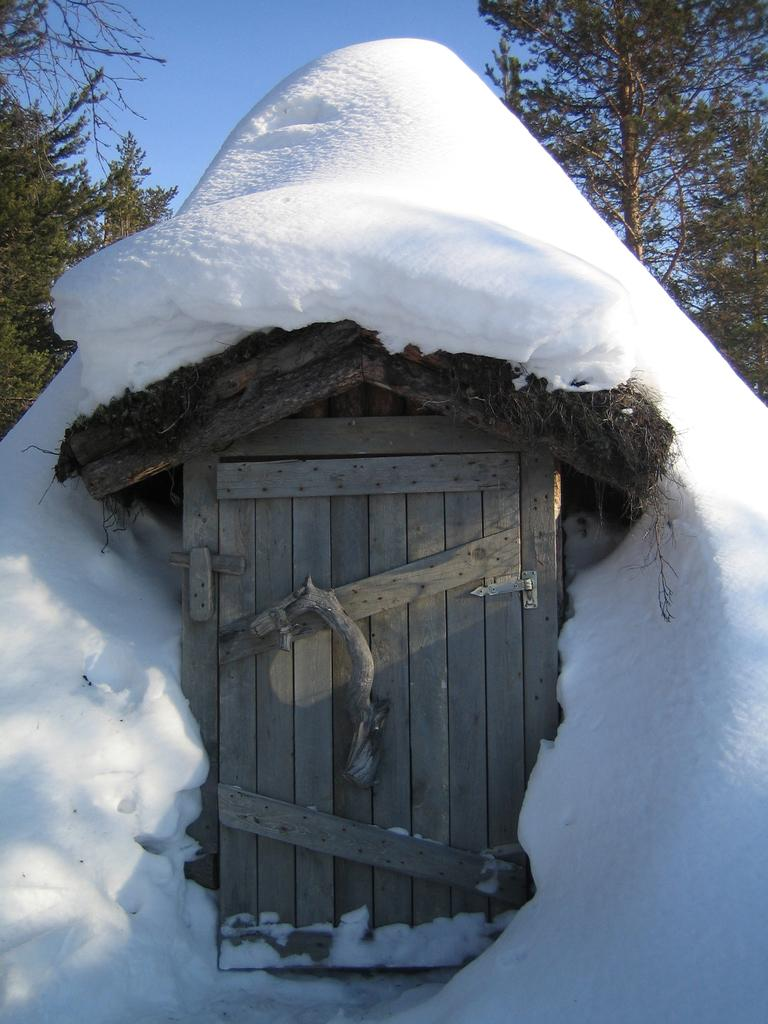What is the main structure in the center of the image? There is a hut in the center of the image. What is covering the hut? There is snow on top of the hut. What can be seen in the background of the image? There are trees in the background of the image. What is the purpose of the kitty in the image? There is no kitty present in the image, so it cannot serve any purpose in the image. 